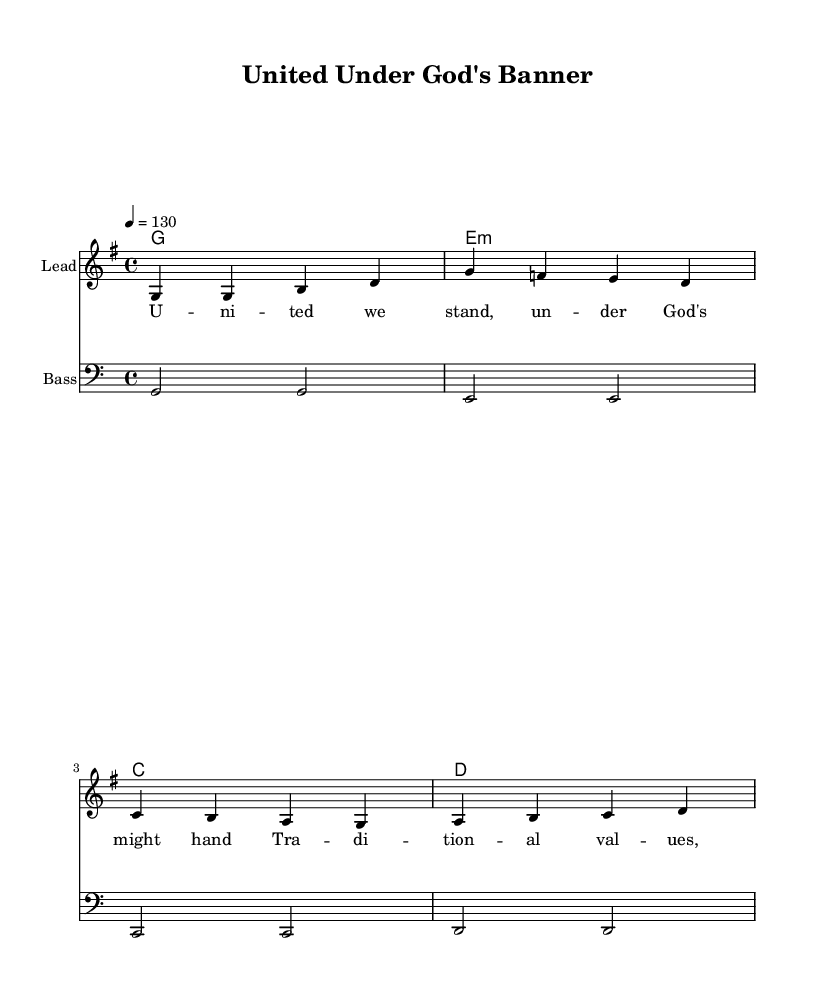What is the key signature of this music? The key signature is G major, which features one sharp (F#). This can be identified from the initial part of the score where the sharp sign appears in the key signature placement.
Answer: G major What is the time signature of this music? The time signature is 4/4, indicated at the beginning of the score. This means there are four beats in each measure, and the quarter note gets one beat.
Answer: 4/4 What is the tempo of the piece? The tempo is marked as 130 beats per minute, listed at the beginning of the score under the global settings.
Answer: 130 How many measures are there in the melody? The melody consists of four measures, as can be counted by the bar lines separating the musical phrases within the melody section.
Answer: Four What is the starting note of the melody? The melody begins on the note G, which is shown as the first note on the staff under the melody section.
Answer: G What type of harmonies are used in this piece? The harmonies are presented in a chord mode format. The chords used are G major, E minor, C major, and D major, as seen in the harmonies section of the score.
Answer: Major and minor chords What is the theme of the song based on the lyrics? The theme revolves around unity and traditional values, as conveyed in the lyrics that emphasize standing united under God’s guidance. The content reflects a conservative outlook.
Answer: Unity and tradition 